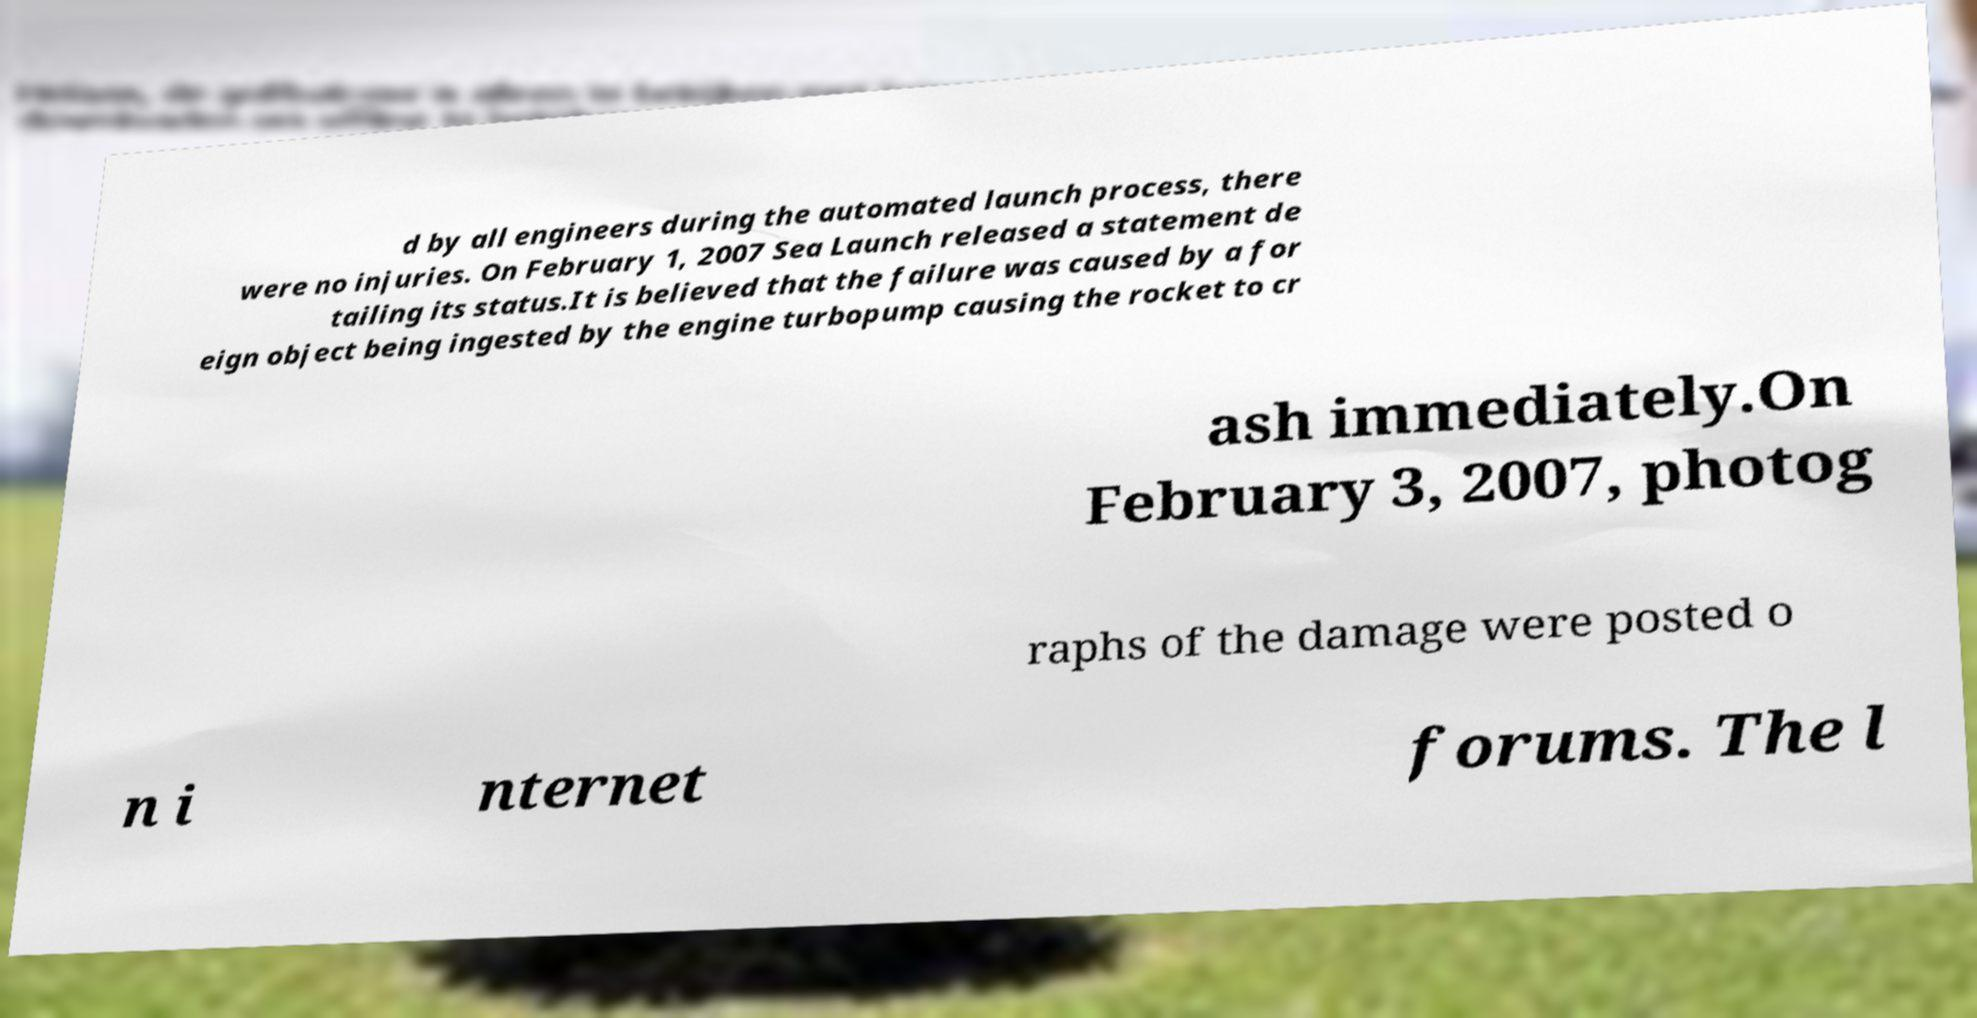For documentation purposes, I need the text within this image transcribed. Could you provide that? d by all engineers during the automated launch process, there were no injuries. On February 1, 2007 Sea Launch released a statement de tailing its status.It is believed that the failure was caused by a for eign object being ingested by the engine turbopump causing the rocket to cr ash immediately.On February 3, 2007, photog raphs of the damage were posted o n i nternet forums. The l 